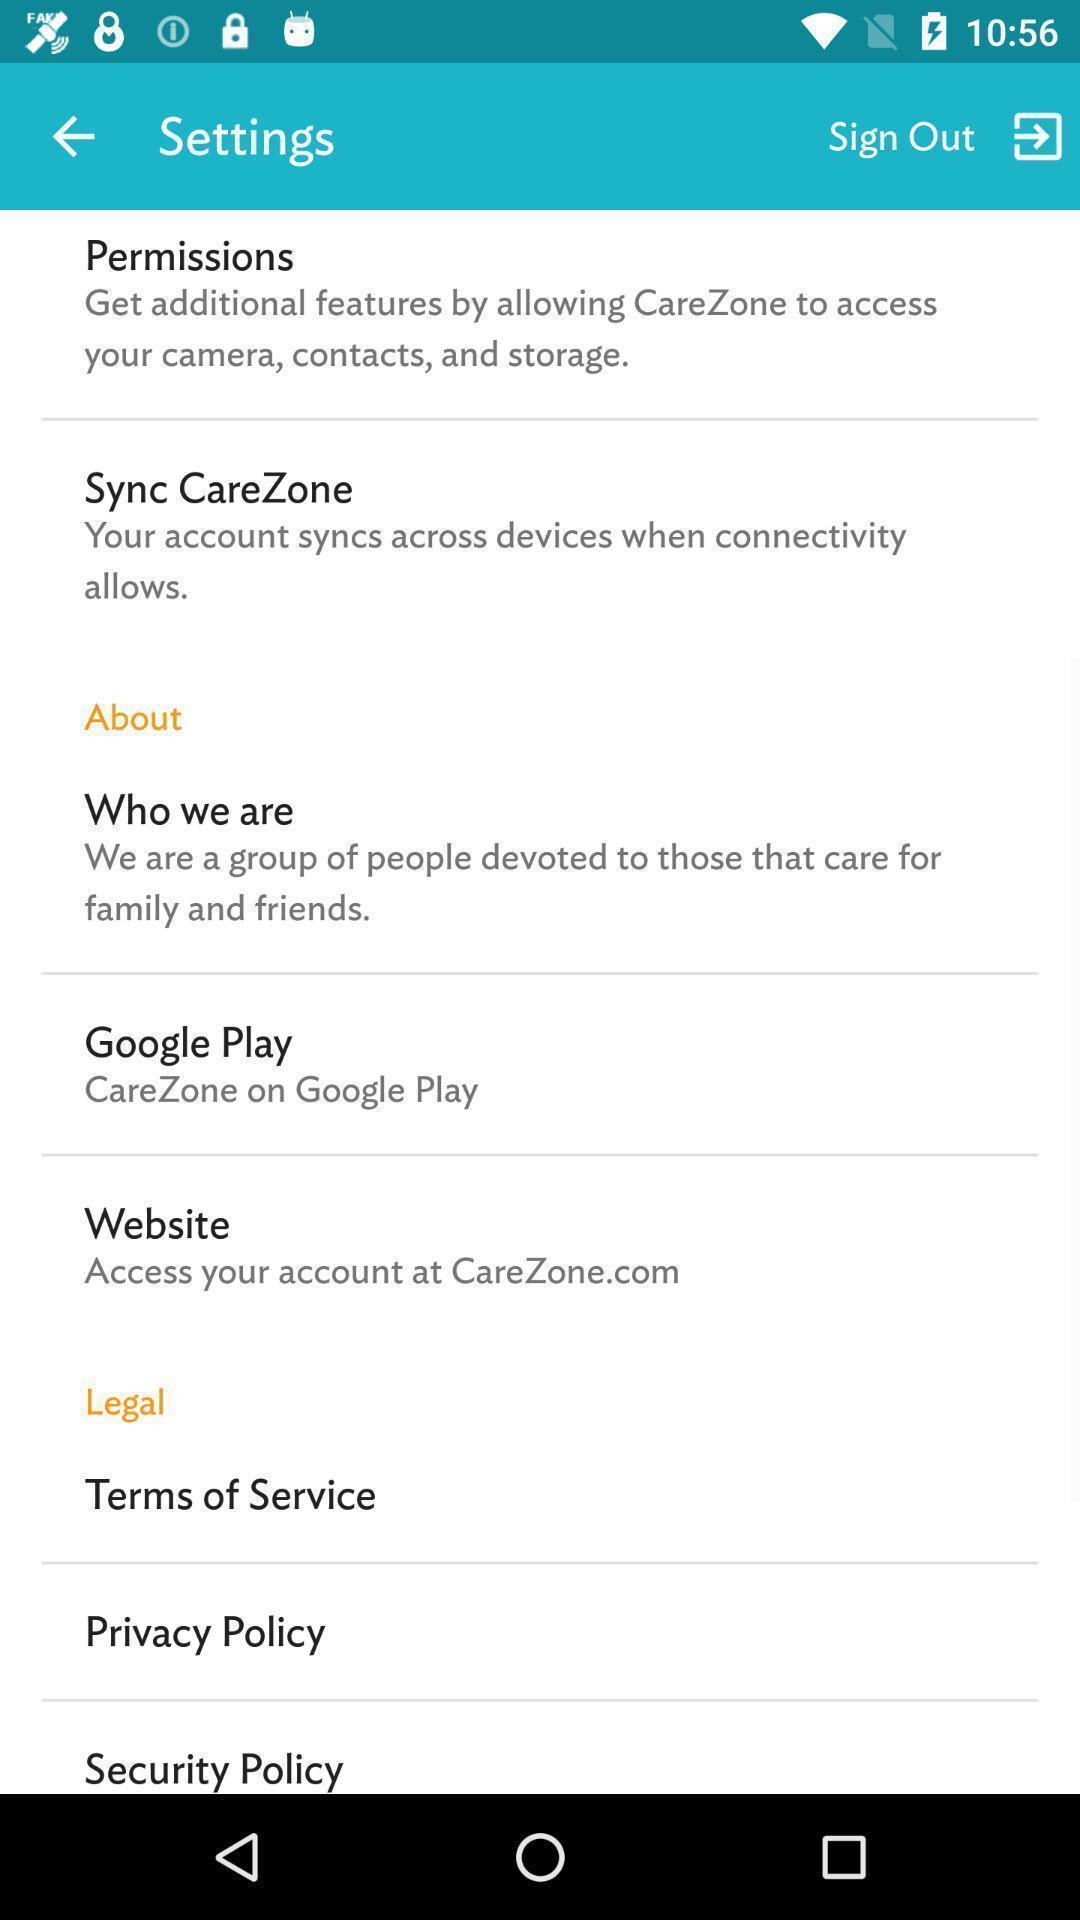Summarize the main components in this picture. Settings page of a healthcare app. 